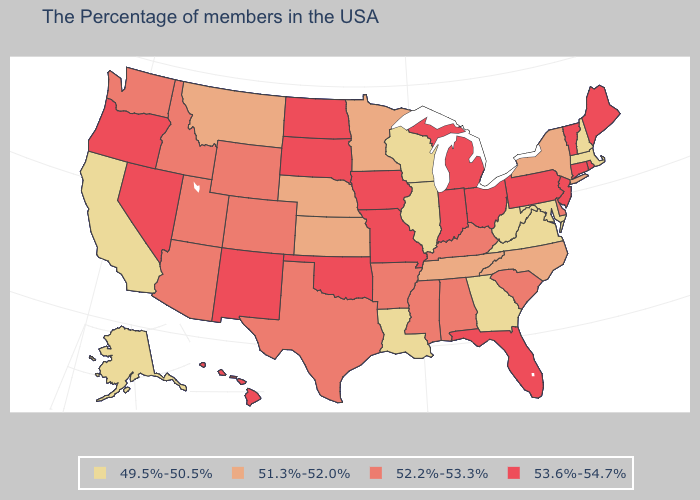Does the first symbol in the legend represent the smallest category?
Short answer required. Yes. What is the highest value in the USA?
Keep it brief. 53.6%-54.7%. Which states have the lowest value in the USA?
Keep it brief. Massachusetts, New Hampshire, Maryland, Virginia, West Virginia, Georgia, Wisconsin, Illinois, Louisiana, California, Alaska. What is the lowest value in states that border Maine?
Write a very short answer. 49.5%-50.5%. Name the states that have a value in the range 51.3%-52.0%?
Keep it brief. New York, North Carolina, Tennessee, Minnesota, Kansas, Nebraska, Montana. Which states have the lowest value in the USA?
Give a very brief answer. Massachusetts, New Hampshire, Maryland, Virginia, West Virginia, Georgia, Wisconsin, Illinois, Louisiana, California, Alaska. What is the value of Arkansas?
Concise answer only. 52.2%-53.3%. Does North Carolina have the highest value in the USA?
Answer briefly. No. What is the highest value in states that border Georgia?
Quick response, please. 53.6%-54.7%. How many symbols are there in the legend?
Concise answer only. 4. Which states have the highest value in the USA?
Give a very brief answer. Maine, Rhode Island, Vermont, Connecticut, New Jersey, Pennsylvania, Ohio, Florida, Michigan, Indiana, Missouri, Iowa, Oklahoma, South Dakota, North Dakota, New Mexico, Nevada, Oregon, Hawaii. Name the states that have a value in the range 49.5%-50.5%?
Concise answer only. Massachusetts, New Hampshire, Maryland, Virginia, West Virginia, Georgia, Wisconsin, Illinois, Louisiana, California, Alaska. What is the lowest value in the USA?
Concise answer only. 49.5%-50.5%. What is the value of Kansas?
Keep it brief. 51.3%-52.0%. Among the states that border Indiana , which have the highest value?
Keep it brief. Ohio, Michigan. 